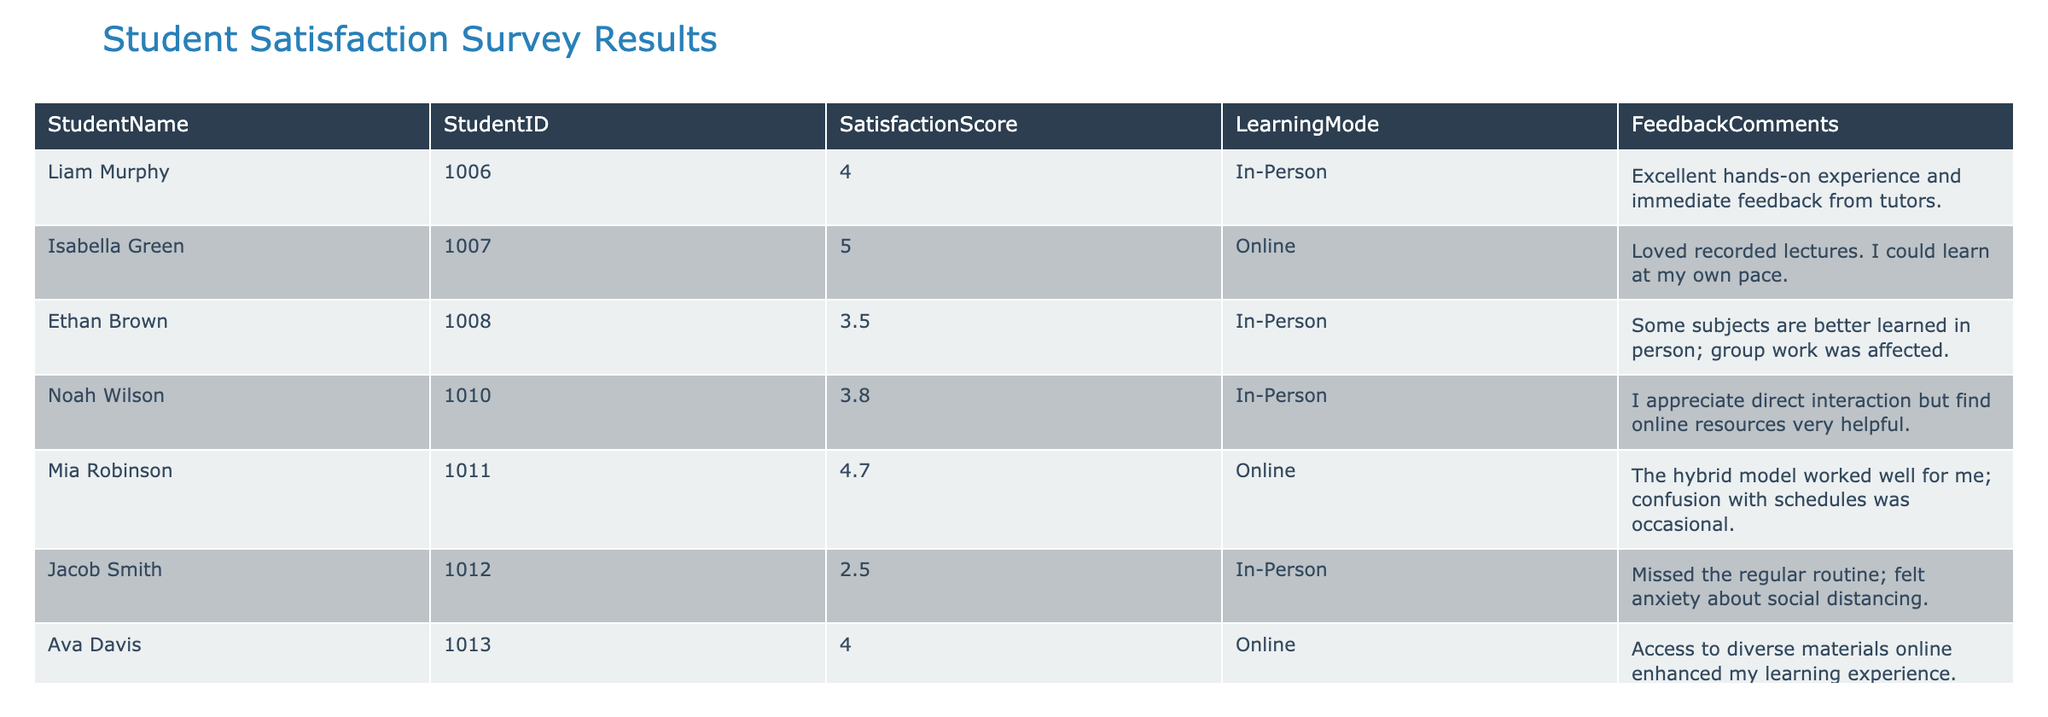What is the highest satisfaction score recorded in the survey? By reviewing the SatisfactionScore column, the highest value is found. The maximum score listed is 5.0, which belongs to Isabella Green who participated in online learning.
Answer: 5.0 Which learning mode do most students prefer based on the data? Checking the LearningMode column counts how many students opted for each mode. In this case, both In-Person and Online have four students, leading to a tie between the two.
Answer: Tie between In-Person and Online What is the average satisfaction score for Online learning? To find the average for Online learning, identify scores in the SatisfactionScore column corresponding to Online. The scores are 5.0, 4.7, 4.0, and 4.3, totaling 18.0. Dividing this sum by 4 (the number of online students) gives an average of 4.5.
Answer: 4.5 Did any student express difficulty with online learning? Looking through the FeedbackComments for Online learners, Mia Robinson notes confusion with schedules. This implies some difficulty or challenges faced.
Answer: Yes How many students reported a satisfaction score of more than 4.0? Count individual satisfaction scores greater than 4.0 in the SatisfactionScore column. These scores are 4.0 (Ava Davis), 4.3 (Amelia Martinez), 4.7 (Mia Robinson), and 5.0 (Isabella Green), totaling four students.
Answer: 4 What is the difference in average satisfaction scores between In-Person and Online learning? Calculate each mode's average score as follows: For In-Person, scores are 4.0, 3.5, 3.8, and 2.5, totaling 13.8, resulting in an average of 3.45 when divided by 4. For Online, again the total is 18.0 with an average of 4.5. The difference in averages is 4.5 - 3.45, which equals 1.05.
Answer: 1.05 Was there a comment about anxiety related to In-Person learning? Examine the FeedbackComments for In-Person learners. Jacob Smith specifically mentions feeling anxiety about social distancing, indicating a clear connection to his in-person experience.
Answer: Yes Which student had the lowest satisfaction score, and what was their feedback? Review the SatisfactionScore column to find the lowest score, which is 2.5 from Jacob Smith. His feedback remarks about missing the regular routine and feeling anxious about social distancing highlight his dissatisfaction.
Answer: Jacob Smith, 2.5, "Missed the regular routine; felt anxiety about social distancing." How does the average satisfaction score of the In-Person students compare to that of the Online students? The average for In-Person learners, calculated as mentioned before, is 3.45, while the Online learners' average is 4.5. Comparing these averages shows that Online students had a higher satisfaction score by 1.05.
Answer: Online students score higher by 1.05 